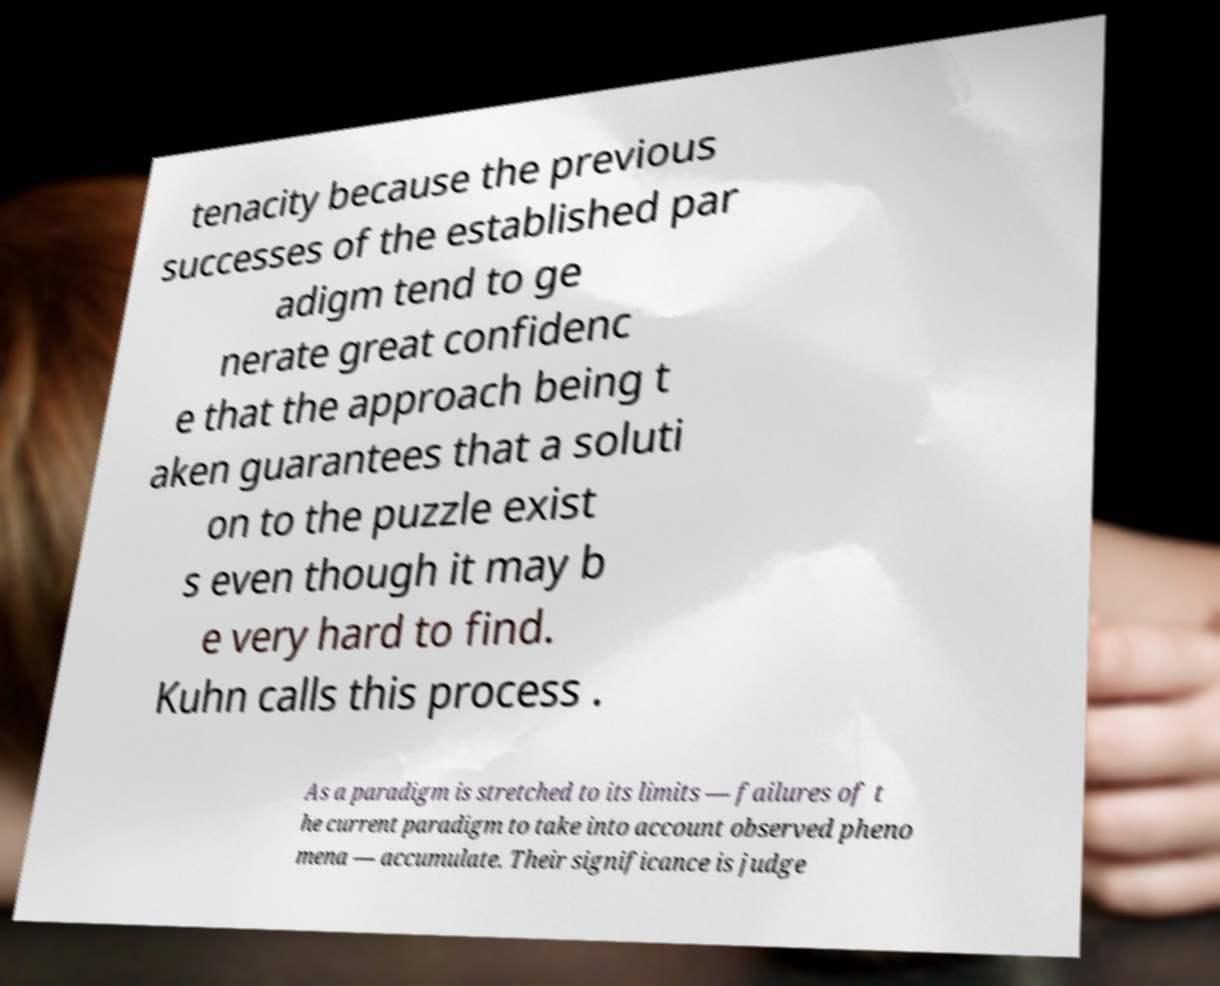Please identify and transcribe the text found in this image. tenacity because the previous successes of the established par adigm tend to ge nerate great confidenc e that the approach being t aken guarantees that a soluti on to the puzzle exist s even though it may b e very hard to find. Kuhn calls this process . As a paradigm is stretched to its limits — failures of t he current paradigm to take into account observed pheno mena — accumulate. Their significance is judge 